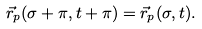<formula> <loc_0><loc_0><loc_500><loc_500>\vec { r } _ { p } ( \sigma + \pi , t + \pi ) = \vec { r } _ { p } ( \sigma , t ) .</formula> 